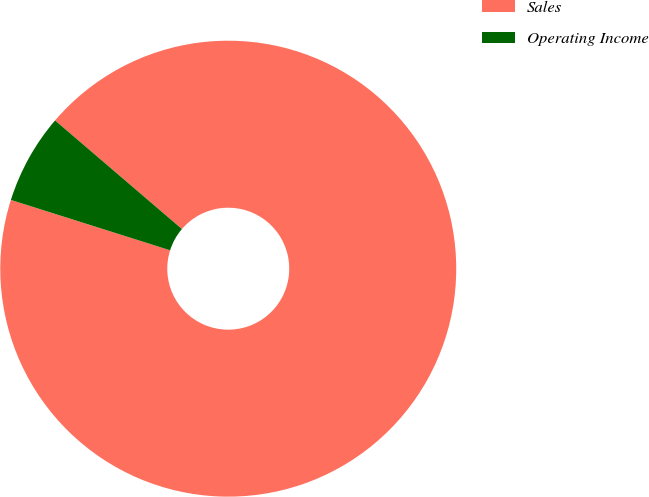<chart> <loc_0><loc_0><loc_500><loc_500><pie_chart><fcel>Sales<fcel>Operating Income<nl><fcel>93.61%<fcel>6.39%<nl></chart> 